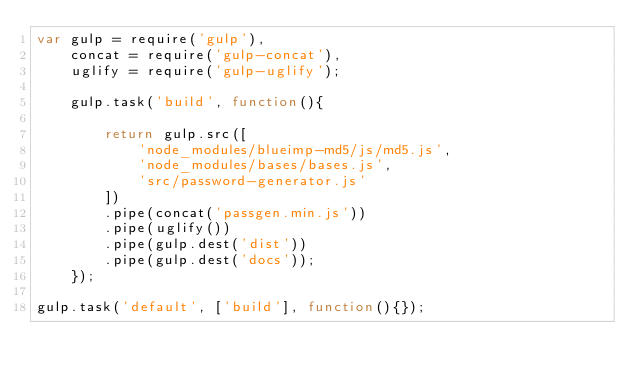<code> <loc_0><loc_0><loc_500><loc_500><_JavaScript_>var gulp = require('gulp'),
    concat = require('gulp-concat'),
    uglify = require('gulp-uglify');

	gulp.task('build', function(){

		return gulp.src([
			'node_modules/blueimp-md5/js/md5.js',
			'node_modules/bases/bases.js',
			'src/password-generator.js'
		])
		.pipe(concat('passgen.min.js'))
		.pipe(uglify())
		.pipe(gulp.dest('dist'))
		.pipe(gulp.dest('docs'));
	});

gulp.task('default', ['build'], function(){});
</code> 